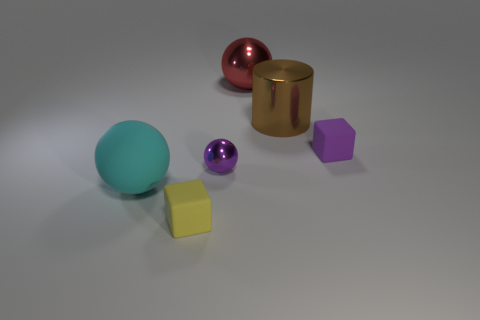Are there more big metallic things behind the purple ball than cyan objects?
Your answer should be very brief. Yes. Are there any shiny things of the same color as the big metal cylinder?
Your answer should be compact. No. What size is the cyan matte thing?
Provide a short and direct response. Large. Do the cylinder and the rubber sphere have the same color?
Give a very brief answer. No. How many things are either tiny green rubber balls or large things right of the cyan thing?
Your answer should be compact. 2. What number of large brown things are to the left of the small ball that is to the left of the matte cube behind the small yellow matte block?
Offer a terse response. 0. What is the material of the other object that is the same color as the small shiny object?
Give a very brief answer. Rubber. What number of big brown metallic objects are there?
Keep it short and to the point. 1. Does the matte cube behind the cyan matte thing have the same size as the large cyan ball?
Offer a terse response. No. How many matte objects are either red things or purple spheres?
Make the answer very short. 0. 